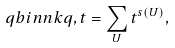<formula> <loc_0><loc_0><loc_500><loc_500>\ q b i n { n } { k } { q , t } = \sum _ { U } t ^ { s ( U ) } ,</formula> 